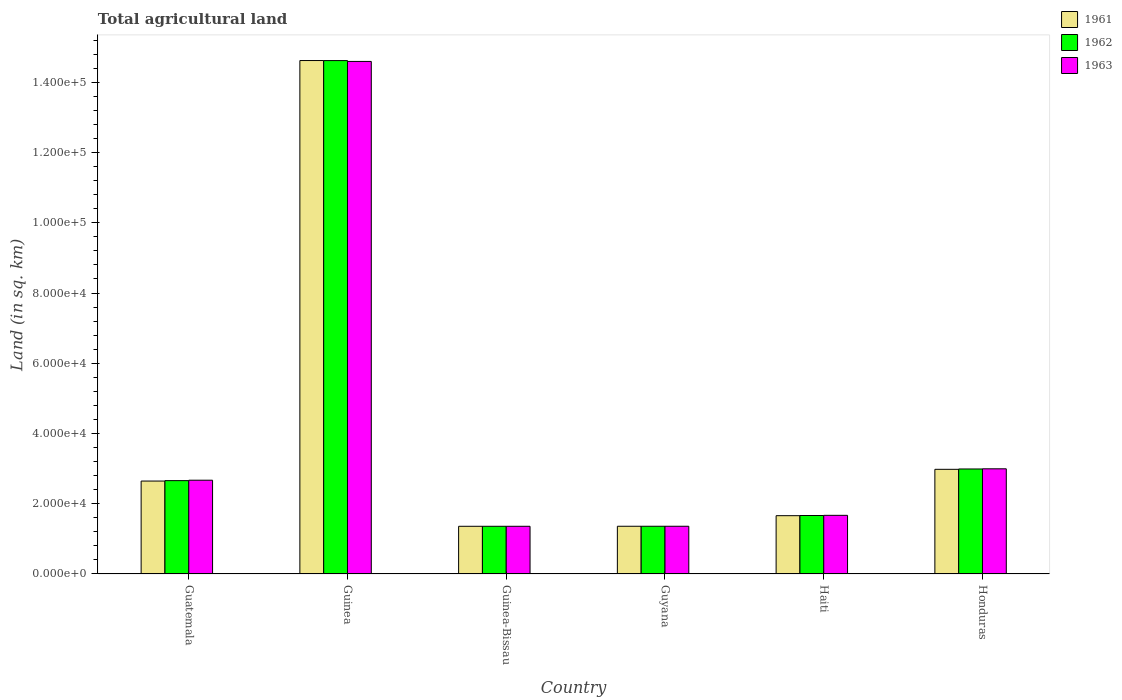How many different coloured bars are there?
Offer a very short reply. 3. Are the number of bars per tick equal to the number of legend labels?
Offer a very short reply. Yes. Are the number of bars on each tick of the X-axis equal?
Keep it short and to the point. Yes. How many bars are there on the 1st tick from the right?
Your answer should be compact. 3. What is the label of the 4th group of bars from the left?
Keep it short and to the point. Guyana. What is the total agricultural land in 1962 in Haiti?
Keep it short and to the point. 1.66e+04. Across all countries, what is the maximum total agricultural land in 1962?
Your answer should be compact. 1.46e+05. Across all countries, what is the minimum total agricultural land in 1961?
Your answer should be compact. 1.36e+04. In which country was the total agricultural land in 1962 maximum?
Offer a very short reply. Guinea. In which country was the total agricultural land in 1961 minimum?
Make the answer very short. Guinea-Bissau. What is the total total agricultural land in 1961 in the graph?
Your response must be concise. 2.46e+05. What is the difference between the total agricultural land in 1962 in Guatemala and that in Guinea-Bissau?
Your answer should be compact. 1.30e+04. What is the difference between the total agricultural land in 1963 in Guinea and the total agricultural land in 1961 in Honduras?
Your answer should be very brief. 1.16e+05. What is the average total agricultural land in 1961 per country?
Offer a very short reply. 4.10e+04. What is the difference between the total agricultural land of/in 1961 and total agricultural land of/in 1963 in Guinea?
Your answer should be very brief. 250. In how many countries, is the total agricultural land in 1962 greater than 116000 sq.km?
Provide a short and direct response. 1. What is the ratio of the total agricultural land in 1962 in Guyana to that in Haiti?
Keep it short and to the point. 0.82. Is the difference between the total agricultural land in 1961 in Guinea-Bissau and Guyana greater than the difference between the total agricultural land in 1963 in Guinea-Bissau and Guyana?
Ensure brevity in your answer.  No. What is the difference between the highest and the second highest total agricultural land in 1962?
Your answer should be compact. -3320. What is the difference between the highest and the lowest total agricultural land in 1961?
Your answer should be compact. 1.33e+05. In how many countries, is the total agricultural land in 1961 greater than the average total agricultural land in 1961 taken over all countries?
Keep it short and to the point. 1. What does the 3rd bar from the left in Guyana represents?
Provide a short and direct response. 1963. What does the 1st bar from the right in Guyana represents?
Provide a short and direct response. 1963. How many bars are there?
Ensure brevity in your answer.  18. Are the values on the major ticks of Y-axis written in scientific E-notation?
Give a very brief answer. Yes. Does the graph contain grids?
Offer a very short reply. No. How are the legend labels stacked?
Offer a very short reply. Vertical. What is the title of the graph?
Provide a succinct answer. Total agricultural land. Does "1976" appear as one of the legend labels in the graph?
Give a very brief answer. No. What is the label or title of the Y-axis?
Your answer should be compact. Land (in sq. km). What is the Land (in sq. km) of 1961 in Guatemala?
Your response must be concise. 2.65e+04. What is the Land (in sq. km) of 1962 in Guatemala?
Provide a short and direct response. 2.66e+04. What is the Land (in sq. km) of 1963 in Guatemala?
Make the answer very short. 2.67e+04. What is the Land (in sq. km) in 1961 in Guinea?
Offer a very short reply. 1.46e+05. What is the Land (in sq. km) in 1962 in Guinea?
Your answer should be very brief. 1.46e+05. What is the Land (in sq. km) of 1963 in Guinea?
Offer a very short reply. 1.46e+05. What is the Land (in sq. km) of 1961 in Guinea-Bissau?
Your answer should be compact. 1.36e+04. What is the Land (in sq. km) of 1962 in Guinea-Bissau?
Your answer should be compact. 1.36e+04. What is the Land (in sq. km) in 1963 in Guinea-Bissau?
Your response must be concise. 1.36e+04. What is the Land (in sq. km) in 1961 in Guyana?
Provide a succinct answer. 1.36e+04. What is the Land (in sq. km) in 1962 in Guyana?
Keep it short and to the point. 1.36e+04. What is the Land (in sq. km) in 1963 in Guyana?
Make the answer very short. 1.36e+04. What is the Land (in sq. km) of 1961 in Haiti?
Your response must be concise. 1.66e+04. What is the Land (in sq. km) in 1962 in Haiti?
Make the answer very short. 1.66e+04. What is the Land (in sq. km) of 1963 in Haiti?
Your answer should be very brief. 1.67e+04. What is the Land (in sq. km) of 1961 in Honduras?
Give a very brief answer. 2.98e+04. What is the Land (in sq. km) of 1962 in Honduras?
Ensure brevity in your answer.  2.99e+04. What is the Land (in sq. km) in 1963 in Honduras?
Offer a very short reply. 3.00e+04. Across all countries, what is the maximum Land (in sq. km) in 1961?
Your answer should be compact. 1.46e+05. Across all countries, what is the maximum Land (in sq. km) of 1962?
Offer a very short reply. 1.46e+05. Across all countries, what is the maximum Land (in sq. km) in 1963?
Make the answer very short. 1.46e+05. Across all countries, what is the minimum Land (in sq. km) of 1961?
Offer a very short reply. 1.36e+04. Across all countries, what is the minimum Land (in sq. km) of 1962?
Provide a succinct answer. 1.36e+04. Across all countries, what is the minimum Land (in sq. km) of 1963?
Your answer should be very brief. 1.36e+04. What is the total Land (in sq. km) of 1961 in the graph?
Provide a short and direct response. 2.46e+05. What is the total Land (in sq. km) of 1962 in the graph?
Your response must be concise. 2.46e+05. What is the total Land (in sq. km) of 1963 in the graph?
Offer a terse response. 2.46e+05. What is the difference between the Land (in sq. km) of 1961 in Guatemala and that in Guinea?
Provide a short and direct response. -1.20e+05. What is the difference between the Land (in sq. km) in 1962 in Guatemala and that in Guinea?
Offer a terse response. -1.20e+05. What is the difference between the Land (in sq. km) in 1963 in Guatemala and that in Guinea?
Your answer should be very brief. -1.19e+05. What is the difference between the Land (in sq. km) of 1961 in Guatemala and that in Guinea-Bissau?
Your response must be concise. 1.29e+04. What is the difference between the Land (in sq. km) in 1962 in Guatemala and that in Guinea-Bissau?
Your response must be concise. 1.30e+04. What is the difference between the Land (in sq. km) in 1963 in Guatemala and that in Guinea-Bissau?
Your answer should be very brief. 1.31e+04. What is the difference between the Land (in sq. km) of 1961 in Guatemala and that in Guyana?
Your answer should be compact. 1.29e+04. What is the difference between the Land (in sq. km) in 1962 in Guatemala and that in Guyana?
Your response must be concise. 1.30e+04. What is the difference between the Land (in sq. km) in 1963 in Guatemala and that in Guyana?
Ensure brevity in your answer.  1.31e+04. What is the difference between the Land (in sq. km) of 1961 in Guatemala and that in Haiti?
Your answer should be compact. 9860. What is the difference between the Land (in sq. km) of 1962 in Guatemala and that in Haiti?
Keep it short and to the point. 9930. What is the difference between the Land (in sq. km) in 1963 in Guatemala and that in Haiti?
Ensure brevity in your answer.  10000. What is the difference between the Land (in sq. km) in 1961 in Guatemala and that in Honduras?
Provide a succinct answer. -3340. What is the difference between the Land (in sq. km) of 1962 in Guatemala and that in Honduras?
Provide a succinct answer. -3320. What is the difference between the Land (in sq. km) of 1963 in Guatemala and that in Honduras?
Provide a short and direct response. -3250. What is the difference between the Land (in sq. km) in 1961 in Guinea and that in Guinea-Bissau?
Provide a short and direct response. 1.33e+05. What is the difference between the Land (in sq. km) of 1962 in Guinea and that in Guinea-Bissau?
Offer a terse response. 1.33e+05. What is the difference between the Land (in sq. km) in 1963 in Guinea and that in Guinea-Bissau?
Ensure brevity in your answer.  1.32e+05. What is the difference between the Land (in sq. km) in 1961 in Guinea and that in Guyana?
Give a very brief answer. 1.33e+05. What is the difference between the Land (in sq. km) in 1962 in Guinea and that in Guyana?
Your answer should be compact. 1.33e+05. What is the difference between the Land (in sq. km) of 1963 in Guinea and that in Guyana?
Offer a very short reply. 1.32e+05. What is the difference between the Land (in sq. km) of 1961 in Guinea and that in Haiti?
Your answer should be compact. 1.30e+05. What is the difference between the Land (in sq. km) in 1962 in Guinea and that in Haiti?
Provide a short and direct response. 1.30e+05. What is the difference between the Land (in sq. km) of 1963 in Guinea and that in Haiti?
Provide a short and direct response. 1.29e+05. What is the difference between the Land (in sq. km) in 1961 in Guinea and that in Honduras?
Provide a succinct answer. 1.16e+05. What is the difference between the Land (in sq. km) in 1962 in Guinea and that in Honduras?
Offer a very short reply. 1.16e+05. What is the difference between the Land (in sq. km) in 1963 in Guinea and that in Honduras?
Provide a succinct answer. 1.16e+05. What is the difference between the Land (in sq. km) in 1961 in Guinea-Bissau and that in Guyana?
Keep it short and to the point. -10. What is the difference between the Land (in sq. km) of 1961 in Guinea-Bissau and that in Haiti?
Provide a short and direct response. -3020. What is the difference between the Land (in sq. km) in 1962 in Guinea-Bissau and that in Haiti?
Your answer should be compact. -3070. What is the difference between the Land (in sq. km) of 1963 in Guinea-Bissau and that in Haiti?
Offer a very short reply. -3120. What is the difference between the Land (in sq. km) in 1961 in Guinea-Bissau and that in Honduras?
Give a very brief answer. -1.62e+04. What is the difference between the Land (in sq. km) in 1962 in Guinea-Bissau and that in Honduras?
Provide a succinct answer. -1.63e+04. What is the difference between the Land (in sq. km) of 1963 in Guinea-Bissau and that in Honduras?
Offer a terse response. -1.64e+04. What is the difference between the Land (in sq. km) in 1961 in Guyana and that in Haiti?
Offer a very short reply. -3010. What is the difference between the Land (in sq. km) in 1962 in Guyana and that in Haiti?
Your answer should be very brief. -3060. What is the difference between the Land (in sq. km) of 1963 in Guyana and that in Haiti?
Your response must be concise. -3110. What is the difference between the Land (in sq. km) of 1961 in Guyana and that in Honduras?
Your answer should be compact. -1.62e+04. What is the difference between the Land (in sq. km) of 1962 in Guyana and that in Honduras?
Provide a succinct answer. -1.63e+04. What is the difference between the Land (in sq. km) of 1963 in Guyana and that in Honduras?
Offer a terse response. -1.64e+04. What is the difference between the Land (in sq. km) of 1961 in Haiti and that in Honduras?
Ensure brevity in your answer.  -1.32e+04. What is the difference between the Land (in sq. km) of 1962 in Haiti and that in Honduras?
Your answer should be compact. -1.32e+04. What is the difference between the Land (in sq. km) in 1963 in Haiti and that in Honduras?
Make the answer very short. -1.32e+04. What is the difference between the Land (in sq. km) of 1961 in Guatemala and the Land (in sq. km) of 1962 in Guinea?
Give a very brief answer. -1.20e+05. What is the difference between the Land (in sq. km) in 1961 in Guatemala and the Land (in sq. km) in 1963 in Guinea?
Provide a short and direct response. -1.19e+05. What is the difference between the Land (in sq. km) in 1962 in Guatemala and the Land (in sq. km) in 1963 in Guinea?
Provide a succinct answer. -1.19e+05. What is the difference between the Land (in sq. km) of 1961 in Guatemala and the Land (in sq. km) of 1962 in Guinea-Bissau?
Offer a terse response. 1.29e+04. What is the difference between the Land (in sq. km) in 1961 in Guatemala and the Land (in sq. km) in 1963 in Guinea-Bissau?
Your response must be concise. 1.29e+04. What is the difference between the Land (in sq. km) of 1962 in Guatemala and the Land (in sq. km) of 1963 in Guinea-Bissau?
Your answer should be very brief. 1.30e+04. What is the difference between the Land (in sq. km) in 1961 in Guatemala and the Land (in sq. km) in 1962 in Guyana?
Provide a succinct answer. 1.29e+04. What is the difference between the Land (in sq. km) in 1961 in Guatemala and the Land (in sq. km) in 1963 in Guyana?
Your answer should be very brief. 1.29e+04. What is the difference between the Land (in sq. km) in 1962 in Guatemala and the Land (in sq. km) in 1963 in Guyana?
Provide a succinct answer. 1.30e+04. What is the difference between the Land (in sq. km) of 1961 in Guatemala and the Land (in sq. km) of 1962 in Haiti?
Provide a short and direct response. 9810. What is the difference between the Land (in sq. km) of 1961 in Guatemala and the Land (in sq. km) of 1963 in Haiti?
Your answer should be very brief. 9760. What is the difference between the Land (in sq. km) in 1962 in Guatemala and the Land (in sq. km) in 1963 in Haiti?
Offer a terse response. 9880. What is the difference between the Land (in sq. km) of 1961 in Guatemala and the Land (in sq. km) of 1962 in Honduras?
Give a very brief answer. -3440. What is the difference between the Land (in sq. km) of 1961 in Guatemala and the Land (in sq. km) of 1963 in Honduras?
Offer a terse response. -3490. What is the difference between the Land (in sq. km) in 1962 in Guatemala and the Land (in sq. km) in 1963 in Honduras?
Give a very brief answer. -3370. What is the difference between the Land (in sq. km) in 1961 in Guinea and the Land (in sq. km) in 1962 in Guinea-Bissau?
Ensure brevity in your answer.  1.33e+05. What is the difference between the Land (in sq. km) in 1961 in Guinea and the Land (in sq. km) in 1963 in Guinea-Bissau?
Keep it short and to the point. 1.33e+05. What is the difference between the Land (in sq. km) of 1962 in Guinea and the Land (in sq. km) of 1963 in Guinea-Bissau?
Provide a succinct answer. 1.33e+05. What is the difference between the Land (in sq. km) in 1961 in Guinea and the Land (in sq. km) in 1962 in Guyana?
Offer a very short reply. 1.33e+05. What is the difference between the Land (in sq. km) in 1961 in Guinea and the Land (in sq. km) in 1963 in Guyana?
Your answer should be very brief. 1.33e+05. What is the difference between the Land (in sq. km) in 1962 in Guinea and the Land (in sq. km) in 1963 in Guyana?
Your answer should be very brief. 1.33e+05. What is the difference between the Land (in sq. km) in 1961 in Guinea and the Land (in sq. km) in 1962 in Haiti?
Offer a terse response. 1.30e+05. What is the difference between the Land (in sq. km) in 1961 in Guinea and the Land (in sq. km) in 1963 in Haiti?
Provide a short and direct response. 1.30e+05. What is the difference between the Land (in sq. km) of 1962 in Guinea and the Land (in sq. km) of 1963 in Haiti?
Offer a very short reply. 1.29e+05. What is the difference between the Land (in sq. km) of 1961 in Guinea and the Land (in sq. km) of 1962 in Honduras?
Ensure brevity in your answer.  1.16e+05. What is the difference between the Land (in sq. km) of 1961 in Guinea and the Land (in sq. km) of 1963 in Honduras?
Offer a very short reply. 1.16e+05. What is the difference between the Land (in sq. km) of 1962 in Guinea and the Land (in sq. km) of 1963 in Honduras?
Your answer should be very brief. 1.16e+05. What is the difference between the Land (in sq. km) of 1961 in Guinea-Bissau and the Land (in sq. km) of 1963 in Guyana?
Offer a terse response. -10. What is the difference between the Land (in sq. km) in 1962 in Guinea-Bissau and the Land (in sq. km) in 1963 in Guyana?
Make the answer very short. -10. What is the difference between the Land (in sq. km) of 1961 in Guinea-Bissau and the Land (in sq. km) of 1962 in Haiti?
Provide a succinct answer. -3070. What is the difference between the Land (in sq. km) in 1961 in Guinea-Bissau and the Land (in sq. km) in 1963 in Haiti?
Offer a terse response. -3120. What is the difference between the Land (in sq. km) of 1962 in Guinea-Bissau and the Land (in sq. km) of 1963 in Haiti?
Your response must be concise. -3120. What is the difference between the Land (in sq. km) in 1961 in Guinea-Bissau and the Land (in sq. km) in 1962 in Honduras?
Provide a short and direct response. -1.63e+04. What is the difference between the Land (in sq. km) in 1961 in Guinea-Bissau and the Land (in sq. km) in 1963 in Honduras?
Provide a short and direct response. -1.64e+04. What is the difference between the Land (in sq. km) of 1962 in Guinea-Bissau and the Land (in sq. km) of 1963 in Honduras?
Offer a terse response. -1.64e+04. What is the difference between the Land (in sq. km) in 1961 in Guyana and the Land (in sq. km) in 1962 in Haiti?
Offer a terse response. -3060. What is the difference between the Land (in sq. km) in 1961 in Guyana and the Land (in sq. km) in 1963 in Haiti?
Your response must be concise. -3110. What is the difference between the Land (in sq. km) in 1962 in Guyana and the Land (in sq. km) in 1963 in Haiti?
Offer a very short reply. -3110. What is the difference between the Land (in sq. km) in 1961 in Guyana and the Land (in sq. km) in 1962 in Honduras?
Give a very brief answer. -1.63e+04. What is the difference between the Land (in sq. km) in 1961 in Guyana and the Land (in sq. km) in 1963 in Honduras?
Offer a terse response. -1.64e+04. What is the difference between the Land (in sq. km) in 1962 in Guyana and the Land (in sq. km) in 1963 in Honduras?
Provide a succinct answer. -1.64e+04. What is the difference between the Land (in sq. km) of 1961 in Haiti and the Land (in sq. km) of 1962 in Honduras?
Your response must be concise. -1.33e+04. What is the difference between the Land (in sq. km) in 1961 in Haiti and the Land (in sq. km) in 1963 in Honduras?
Offer a very short reply. -1.34e+04. What is the difference between the Land (in sq. km) of 1962 in Haiti and the Land (in sq. km) of 1963 in Honduras?
Ensure brevity in your answer.  -1.33e+04. What is the average Land (in sq. km) of 1961 per country?
Your answer should be very brief. 4.10e+04. What is the average Land (in sq. km) in 1962 per country?
Keep it short and to the point. 4.11e+04. What is the average Land (in sq. km) of 1963 per country?
Your answer should be very brief. 4.11e+04. What is the difference between the Land (in sq. km) in 1961 and Land (in sq. km) in 1962 in Guatemala?
Ensure brevity in your answer.  -120. What is the difference between the Land (in sq. km) of 1961 and Land (in sq. km) of 1963 in Guatemala?
Provide a succinct answer. -240. What is the difference between the Land (in sq. km) of 1962 and Land (in sq. km) of 1963 in Guatemala?
Provide a succinct answer. -120. What is the difference between the Land (in sq. km) in 1961 and Land (in sq. km) in 1963 in Guinea?
Ensure brevity in your answer.  250. What is the difference between the Land (in sq. km) in 1962 and Land (in sq. km) in 1963 in Guinea?
Your answer should be compact. 240. What is the difference between the Land (in sq. km) of 1961 and Land (in sq. km) of 1962 in Guinea-Bissau?
Offer a terse response. 0. What is the difference between the Land (in sq. km) in 1962 and Land (in sq. km) in 1963 in Guinea-Bissau?
Ensure brevity in your answer.  0. What is the difference between the Land (in sq. km) in 1961 and Land (in sq. km) in 1963 in Guyana?
Keep it short and to the point. 0. What is the difference between the Land (in sq. km) in 1961 and Land (in sq. km) in 1962 in Haiti?
Your response must be concise. -50. What is the difference between the Land (in sq. km) in 1961 and Land (in sq. km) in 1963 in Haiti?
Your answer should be very brief. -100. What is the difference between the Land (in sq. km) of 1962 and Land (in sq. km) of 1963 in Haiti?
Ensure brevity in your answer.  -50. What is the difference between the Land (in sq. km) of 1961 and Land (in sq. km) of 1962 in Honduras?
Your response must be concise. -100. What is the difference between the Land (in sq. km) of 1961 and Land (in sq. km) of 1963 in Honduras?
Ensure brevity in your answer.  -150. What is the difference between the Land (in sq. km) of 1962 and Land (in sq. km) of 1963 in Honduras?
Provide a succinct answer. -50. What is the ratio of the Land (in sq. km) of 1961 in Guatemala to that in Guinea?
Your answer should be very brief. 0.18. What is the ratio of the Land (in sq. km) in 1962 in Guatemala to that in Guinea?
Offer a very short reply. 0.18. What is the ratio of the Land (in sq. km) of 1963 in Guatemala to that in Guinea?
Provide a succinct answer. 0.18. What is the ratio of the Land (in sq. km) of 1961 in Guatemala to that in Guinea-Bissau?
Offer a terse response. 1.95. What is the ratio of the Land (in sq. km) in 1962 in Guatemala to that in Guinea-Bissau?
Make the answer very short. 1.96. What is the ratio of the Land (in sq. km) in 1963 in Guatemala to that in Guinea-Bissau?
Your response must be concise. 1.97. What is the ratio of the Land (in sq. km) in 1961 in Guatemala to that in Guyana?
Offer a very short reply. 1.95. What is the ratio of the Land (in sq. km) in 1962 in Guatemala to that in Guyana?
Make the answer very short. 1.96. What is the ratio of the Land (in sq. km) in 1963 in Guatemala to that in Guyana?
Your answer should be compact. 1.96. What is the ratio of the Land (in sq. km) in 1961 in Guatemala to that in Haiti?
Provide a succinct answer. 1.59. What is the ratio of the Land (in sq. km) in 1962 in Guatemala to that in Haiti?
Your answer should be compact. 1.6. What is the ratio of the Land (in sq. km) of 1963 in Guatemala to that in Haiti?
Offer a terse response. 1.6. What is the ratio of the Land (in sq. km) in 1961 in Guatemala to that in Honduras?
Ensure brevity in your answer.  0.89. What is the ratio of the Land (in sq. km) in 1962 in Guatemala to that in Honduras?
Provide a succinct answer. 0.89. What is the ratio of the Land (in sq. km) of 1963 in Guatemala to that in Honduras?
Your response must be concise. 0.89. What is the ratio of the Land (in sq. km) in 1961 in Guinea to that in Guinea-Bissau?
Provide a succinct answer. 10.77. What is the ratio of the Land (in sq. km) in 1962 in Guinea to that in Guinea-Bissau?
Offer a very short reply. 10.77. What is the ratio of the Land (in sq. km) in 1963 in Guinea to that in Guinea-Bissau?
Offer a terse response. 10.75. What is the ratio of the Land (in sq. km) of 1961 in Guinea to that in Guyana?
Offer a very short reply. 10.76. What is the ratio of the Land (in sq. km) of 1962 in Guinea to that in Guyana?
Offer a very short reply. 10.76. What is the ratio of the Land (in sq. km) in 1963 in Guinea to that in Guyana?
Offer a very short reply. 10.74. What is the ratio of the Land (in sq. km) of 1961 in Guinea to that in Haiti?
Provide a short and direct response. 8.81. What is the ratio of the Land (in sq. km) of 1962 in Guinea to that in Haiti?
Give a very brief answer. 8.78. What is the ratio of the Land (in sq. km) in 1963 in Guinea to that in Haiti?
Offer a very short reply. 8.74. What is the ratio of the Land (in sq. km) in 1961 in Guinea to that in Honduras?
Offer a very short reply. 4.91. What is the ratio of the Land (in sq. km) in 1962 in Guinea to that in Honduras?
Offer a terse response. 4.89. What is the ratio of the Land (in sq. km) of 1963 in Guinea to that in Honduras?
Your response must be concise. 4.87. What is the ratio of the Land (in sq. km) of 1961 in Guinea-Bissau to that in Guyana?
Make the answer very short. 1. What is the ratio of the Land (in sq. km) of 1962 in Guinea-Bissau to that in Guyana?
Provide a succinct answer. 1. What is the ratio of the Land (in sq. km) in 1963 in Guinea-Bissau to that in Guyana?
Provide a succinct answer. 1. What is the ratio of the Land (in sq. km) of 1961 in Guinea-Bissau to that in Haiti?
Ensure brevity in your answer.  0.82. What is the ratio of the Land (in sq. km) in 1962 in Guinea-Bissau to that in Haiti?
Give a very brief answer. 0.82. What is the ratio of the Land (in sq. km) in 1963 in Guinea-Bissau to that in Haiti?
Provide a succinct answer. 0.81. What is the ratio of the Land (in sq. km) of 1961 in Guinea-Bissau to that in Honduras?
Your answer should be very brief. 0.46. What is the ratio of the Land (in sq. km) of 1962 in Guinea-Bissau to that in Honduras?
Make the answer very short. 0.45. What is the ratio of the Land (in sq. km) of 1963 in Guinea-Bissau to that in Honduras?
Your response must be concise. 0.45. What is the ratio of the Land (in sq. km) of 1961 in Guyana to that in Haiti?
Keep it short and to the point. 0.82. What is the ratio of the Land (in sq. km) of 1962 in Guyana to that in Haiti?
Your response must be concise. 0.82. What is the ratio of the Land (in sq. km) in 1963 in Guyana to that in Haiti?
Your answer should be compact. 0.81. What is the ratio of the Land (in sq. km) of 1961 in Guyana to that in Honduras?
Your response must be concise. 0.46. What is the ratio of the Land (in sq. km) in 1962 in Guyana to that in Honduras?
Provide a succinct answer. 0.45. What is the ratio of the Land (in sq. km) of 1963 in Guyana to that in Honduras?
Ensure brevity in your answer.  0.45. What is the ratio of the Land (in sq. km) in 1961 in Haiti to that in Honduras?
Provide a short and direct response. 0.56. What is the ratio of the Land (in sq. km) of 1962 in Haiti to that in Honduras?
Your answer should be very brief. 0.56. What is the ratio of the Land (in sq. km) in 1963 in Haiti to that in Honduras?
Offer a terse response. 0.56. What is the difference between the highest and the second highest Land (in sq. km) of 1961?
Your answer should be compact. 1.16e+05. What is the difference between the highest and the second highest Land (in sq. km) of 1962?
Your answer should be very brief. 1.16e+05. What is the difference between the highest and the second highest Land (in sq. km) of 1963?
Your answer should be compact. 1.16e+05. What is the difference between the highest and the lowest Land (in sq. km) of 1961?
Your answer should be compact. 1.33e+05. What is the difference between the highest and the lowest Land (in sq. km) in 1962?
Provide a succinct answer. 1.33e+05. What is the difference between the highest and the lowest Land (in sq. km) in 1963?
Provide a short and direct response. 1.32e+05. 